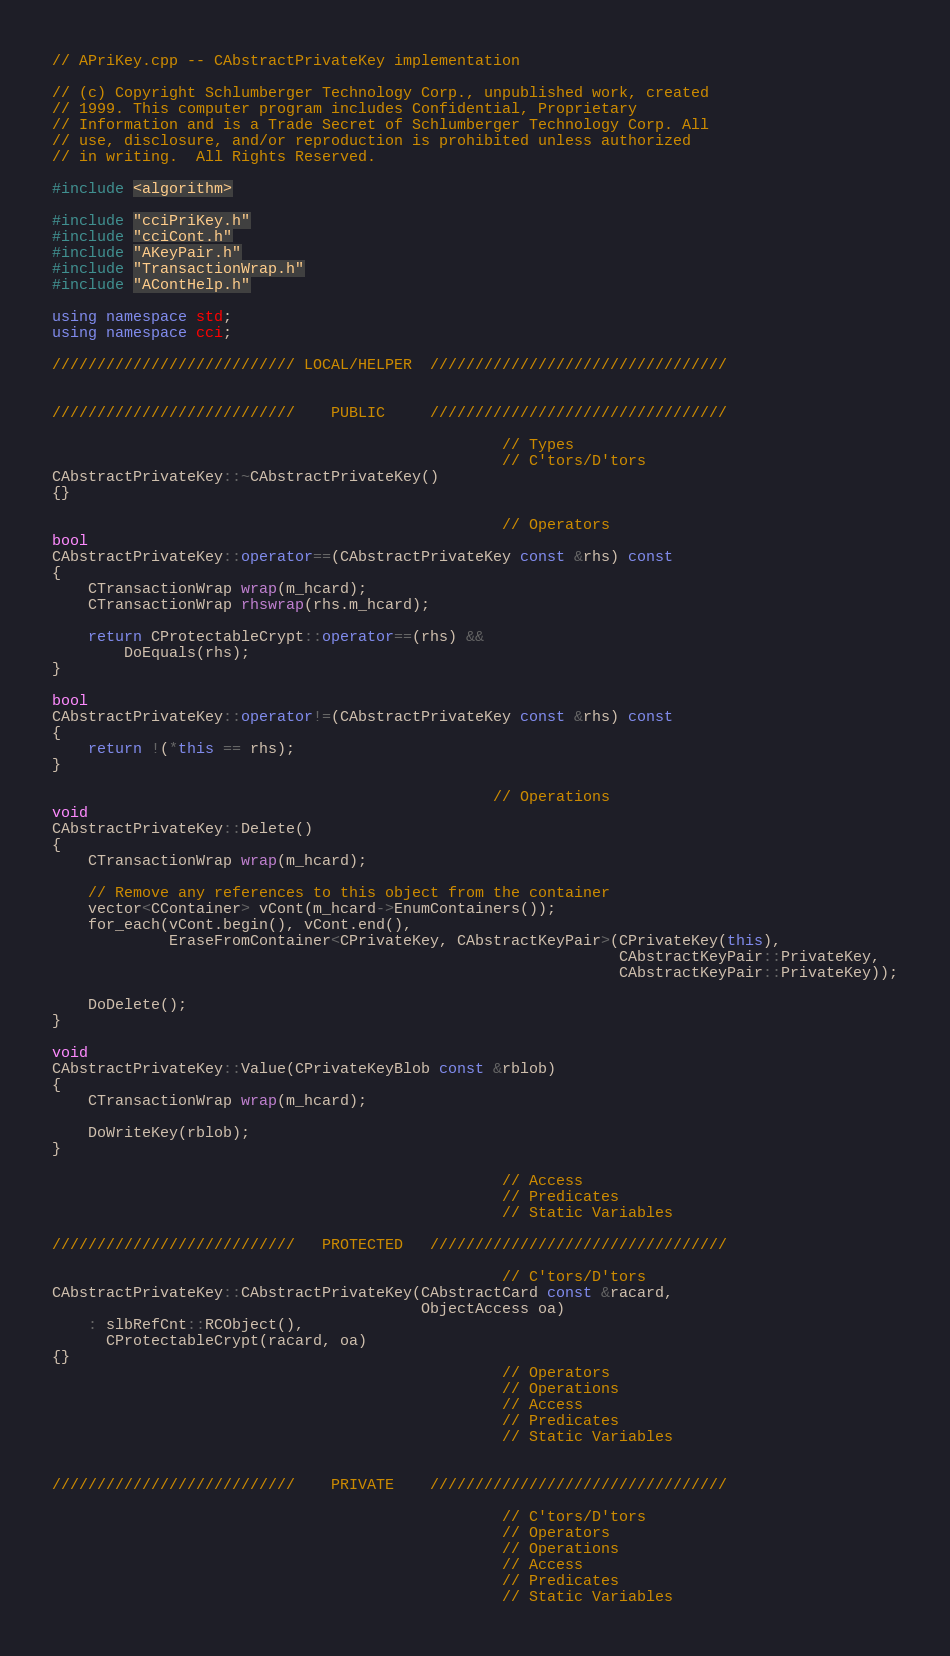<code> <loc_0><loc_0><loc_500><loc_500><_C++_>// APriKey.cpp -- CAbstractPrivateKey implementation

// (c) Copyright Schlumberger Technology Corp., unpublished work, created
// 1999. This computer program includes Confidential, Proprietary
// Information and is a Trade Secret of Schlumberger Technology Corp. All
// use, disclosure, and/or reproduction is prohibited unless authorized
// in writing.  All Rights Reserved.

#include <algorithm>

#include "cciPriKey.h"
#include "cciCont.h"
#include "AKeyPair.h"
#include "TransactionWrap.h"
#include "AContHelp.h"

using namespace std;
using namespace cci;

/////////////////////////// LOCAL/HELPER  /////////////////////////////////


///////////////////////////    PUBLIC     /////////////////////////////////

                                                  // Types
                                                  // C'tors/D'tors
CAbstractPrivateKey::~CAbstractPrivateKey()
{}

                                                  // Operators
bool
CAbstractPrivateKey::operator==(CAbstractPrivateKey const &rhs) const
{
    CTransactionWrap wrap(m_hcard);
    CTransactionWrap rhswrap(rhs.m_hcard);

    return CProtectableCrypt::operator==(rhs) &&
        DoEquals(rhs);
}

bool
CAbstractPrivateKey::operator!=(CAbstractPrivateKey const &rhs) const
{
    return !(*this == rhs);
}

                                                 // Operations
void
CAbstractPrivateKey::Delete()
{
    CTransactionWrap wrap(m_hcard);

    // Remove any references to this object from the container
    vector<CContainer> vCont(m_hcard->EnumContainers());
    for_each(vCont.begin(), vCont.end(),
             EraseFromContainer<CPrivateKey, CAbstractKeyPair>(CPrivateKey(this),
                                                               CAbstractKeyPair::PrivateKey,
                                                               CAbstractKeyPair::PrivateKey));

    DoDelete();
}

void
CAbstractPrivateKey::Value(CPrivateKeyBlob const &rblob)
{
    CTransactionWrap wrap(m_hcard);

    DoWriteKey(rblob);
}

                                                  // Access
                                                  // Predicates
                                                  // Static Variables

///////////////////////////   PROTECTED   /////////////////////////////////

                                                  // C'tors/D'tors
CAbstractPrivateKey::CAbstractPrivateKey(CAbstractCard const &racard,
                                         ObjectAccess oa)
    : slbRefCnt::RCObject(),
      CProtectableCrypt(racard, oa)
{}
                                                  // Operators
                                                  // Operations
                                                  // Access
                                                  // Predicates
                                                  // Static Variables


///////////////////////////    PRIVATE    /////////////////////////////////

                                                  // C'tors/D'tors
                                                  // Operators
                                                  // Operations
                                                  // Access
                                                  // Predicates
                                                  // Static Variables
</code> 